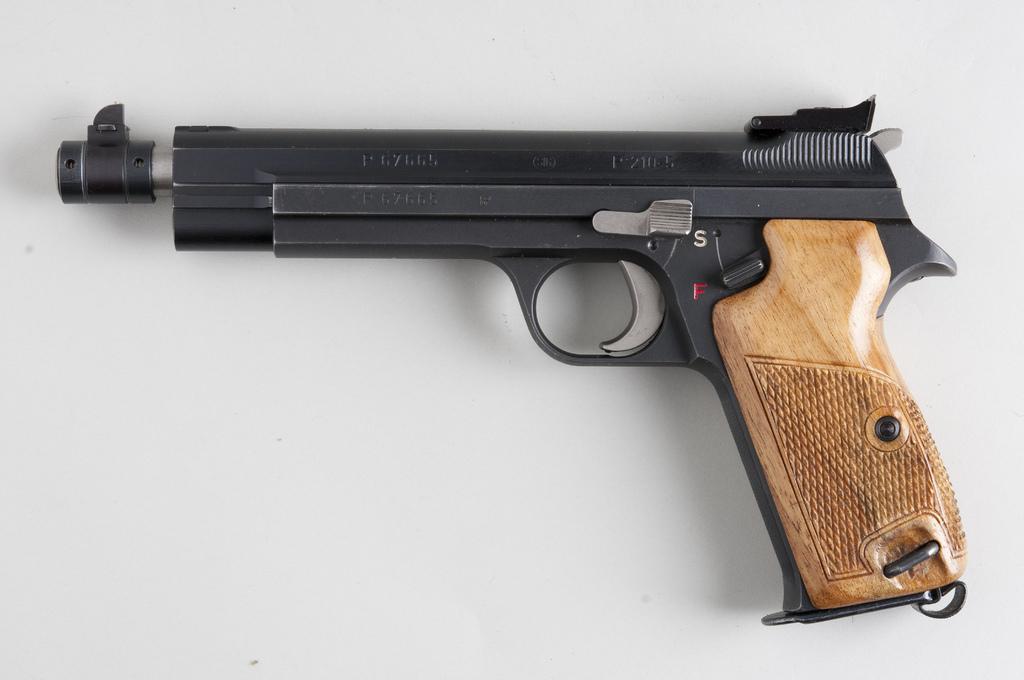What object is the main focus of the image? There is a gun in the image. What is the color of the surface on which the gun is placed? The gun is on a white surface. What type of wool is used to make the shoes in the image? There are no shoes or wool present in the image; it only features a gun on a white surface. 